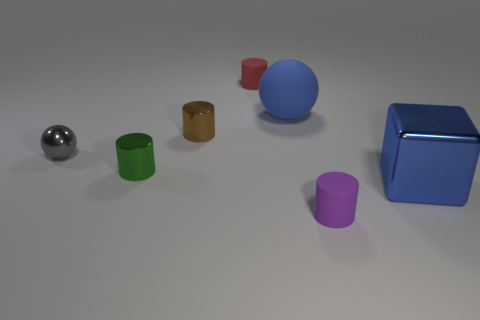What is the small thing in front of the large thing that is to the right of the big blue object that is to the left of the cube made of? The small object in question appears to be a metallic sphere, positioned in front of a large red cylinder, which itself is to the right of a large blue sphere, and all of these objects are to the left of a blue cube that seems to be constructed from a glossy, plastic-like material. 